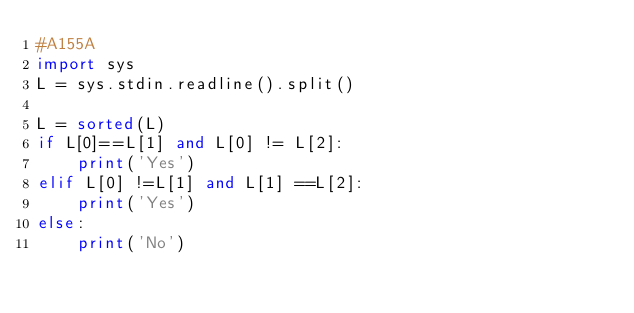<code> <loc_0><loc_0><loc_500><loc_500><_Python_>#A155A
import sys
L = sys.stdin.readline().split()

L = sorted(L)
if L[0]==L[1] and L[0] != L[2]:
    print('Yes')
elif L[0] !=L[1] and L[1] ==L[2]:
    print('Yes')
else:
    print('No')</code> 